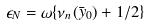<formula> <loc_0><loc_0><loc_500><loc_500>\epsilon _ { N } = \omega \{ { \nu _ { n } } ( \bar { y } _ { 0 } ) + 1 / 2 \}</formula> 